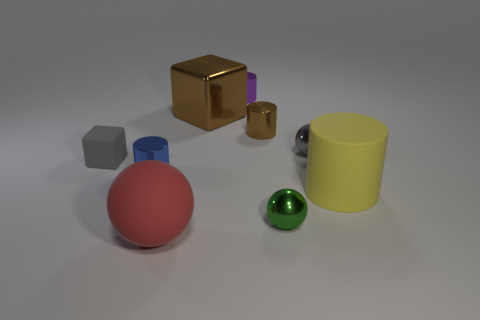There is a big thing that is the same shape as the tiny matte thing; what is it made of?
Keep it short and to the point. Metal. What number of tiny metallic blocks are the same color as the big block?
Provide a succinct answer. 0. There is a gray cube that is made of the same material as the large yellow cylinder; what is its size?
Give a very brief answer. Small. What number of gray objects are either rubber balls or balls?
Your answer should be very brief. 1. What number of purple objects are in front of the brown object to the right of the big cube?
Make the answer very short. 0. Is the number of purple cylinders that are on the left side of the tiny blue metal cylinder greater than the number of matte blocks that are on the right side of the brown metal block?
Provide a short and direct response. No. What is the brown cube made of?
Offer a very short reply. Metal. Are there any purple cylinders that have the same size as the purple metal thing?
Make the answer very short. No. What material is the sphere that is the same size as the green object?
Ensure brevity in your answer.  Metal. How many objects are there?
Keep it short and to the point. 9. 